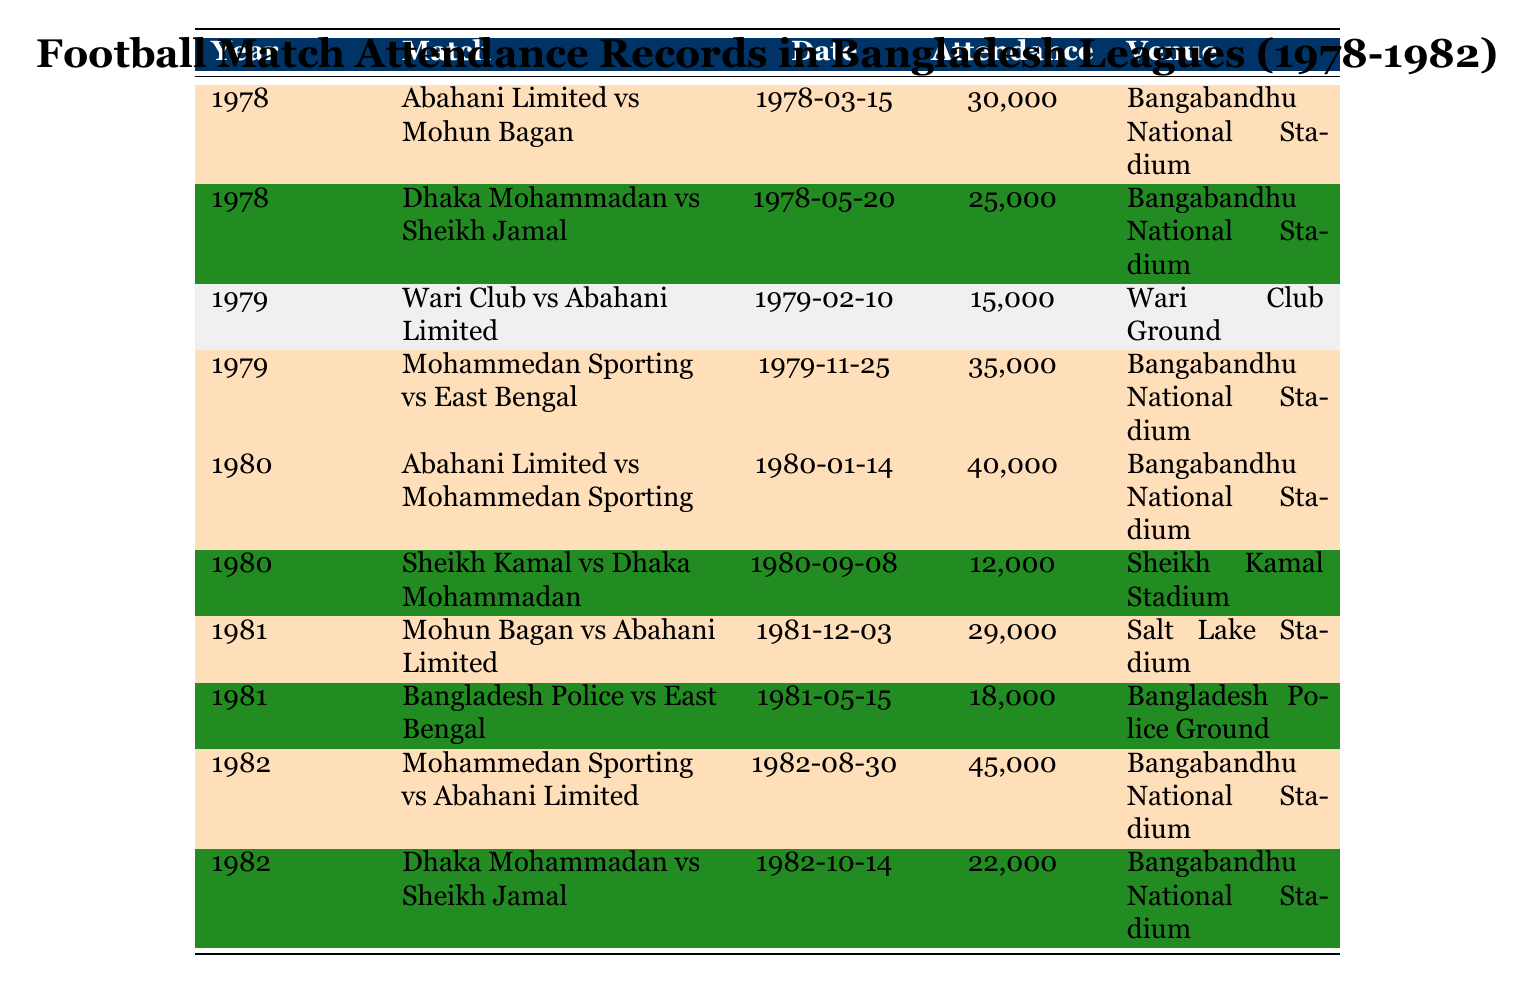What was the highest attendance recorded in the table? The table shows multiple attendance records, and by examining the attendance values, we find that the highest value is 45,000 for the match between Mohammedan Sporting and Abahani Limited in 1982.
Answer: 45000 Which match had the lowest attendance? By checking all the attendance values in the table, the lowest recorded attendance is 12,000 for the match between Sheikh Kamal and Dhaka Mohammadan in 1980.
Answer: 12000 What year did Abahani Limited play against Mohammedan Sporting? The table lists a match between Abahani Limited and Mohammedan Sporting on January 14, 1980, showing the year as 1980.
Answer: 1980 How many matches had an attendance of over 30,000? From inspecting the highlighted attendance figures in the table, there are four matches with an attendance over 30,000: 30,000, 35,000, 40,000, and 45,000.
Answer: 4 Is there a year where more than one highlighted match occurred? Analyzing the highlighted matches by year, 1980 has one highlighted match and thus does not satisfy the criteria. However, 1979 has one highlighted match, and so does 1981. Therefore, the answer is no.
Answer: No What is the average attendance for highlighted matches? The highlighted attendance values are 30,000; 35,000; 40,000; 29,000; and 45,000. Summing these gives 30,000 + 35,000 + 40,000 + 29,000 + 45,000 = 179,000. Dividing by 5 gives an average of 179,000 / 5 = 35,800.
Answer: 35800 Which venue hosted the most highlighted matches? By checking the highlighted matches, we see that all highlighted matches, except for the one in 1981, took place at the Bangabandhu National Stadium. Thus, this venue tops the list with four occurrences.
Answer: Bangabandhu National Stadium What was the attendance difference between the highest and lowest matches? The highest attendance is 45,000 and the lowest is 12,000. The difference is 45,000 - 12,000 = 33,000.
Answer: 33000 Did any match in 1981 exceed 30,000 attendees? The match listed for 1981 between Mohun Bagan and Abahani Limited had an attendance of 29,000, which does not meet the criterion of exceeding 30,000 attendees. Therefore, the answer is no.
Answer: No Which match in 1982 had an attendance of 22,000? In 1982, the match between Dhaka Mohammadan and Sheikh Jamal had an attendance of 22,000, which directly answers this question.
Answer: Dhaka Mohammadan vs Sheikh Jamal 